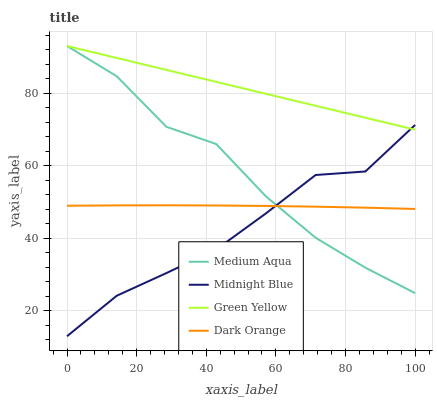Does Midnight Blue have the minimum area under the curve?
Answer yes or no. Yes. Does Green Yellow have the maximum area under the curve?
Answer yes or no. Yes. Does Medium Aqua have the minimum area under the curve?
Answer yes or no. No. Does Medium Aqua have the maximum area under the curve?
Answer yes or no. No. Is Green Yellow the smoothest?
Answer yes or no. Yes. Is Medium Aqua the roughest?
Answer yes or no. Yes. Is Medium Aqua the smoothest?
Answer yes or no. No. Is Green Yellow the roughest?
Answer yes or no. No. Does Midnight Blue have the lowest value?
Answer yes or no. Yes. Does Medium Aqua have the lowest value?
Answer yes or no. No. Does Medium Aqua have the highest value?
Answer yes or no. Yes. Does Midnight Blue have the highest value?
Answer yes or no. No. Is Dark Orange less than Green Yellow?
Answer yes or no. Yes. Is Green Yellow greater than Dark Orange?
Answer yes or no. Yes. Does Medium Aqua intersect Midnight Blue?
Answer yes or no. Yes. Is Medium Aqua less than Midnight Blue?
Answer yes or no. No. Is Medium Aqua greater than Midnight Blue?
Answer yes or no. No. Does Dark Orange intersect Green Yellow?
Answer yes or no. No. 